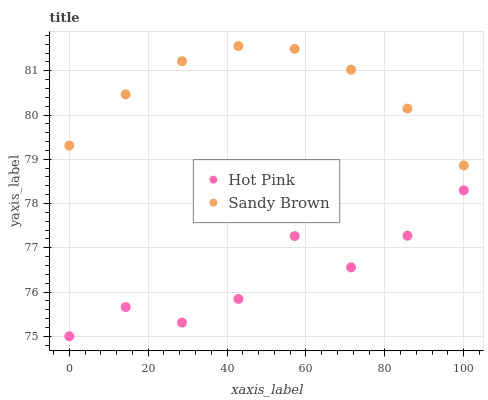Does Hot Pink have the minimum area under the curve?
Answer yes or no. Yes. Does Sandy Brown have the maximum area under the curve?
Answer yes or no. Yes. Does Sandy Brown have the minimum area under the curve?
Answer yes or no. No. Is Sandy Brown the smoothest?
Answer yes or no. Yes. Is Hot Pink the roughest?
Answer yes or no. Yes. Is Sandy Brown the roughest?
Answer yes or no. No. Does Hot Pink have the lowest value?
Answer yes or no. Yes. Does Sandy Brown have the lowest value?
Answer yes or no. No. Does Sandy Brown have the highest value?
Answer yes or no. Yes. Is Hot Pink less than Sandy Brown?
Answer yes or no. Yes. Is Sandy Brown greater than Hot Pink?
Answer yes or no. Yes. Does Hot Pink intersect Sandy Brown?
Answer yes or no. No. 